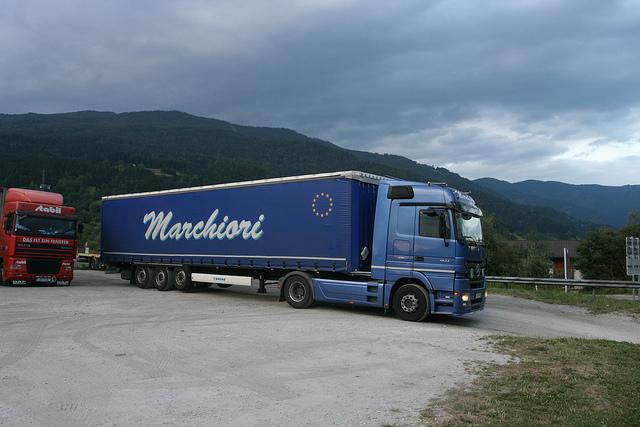What style of writing is on the trailer?
Be succinct. Cursive. How many trucks can you see?
Be succinct. 2. Are there clouds?
Keep it brief. Yes. Is the sky overcast?
Keep it brief. Yes. 